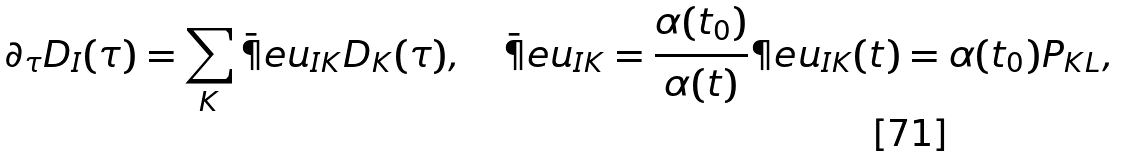Convert formula to latex. <formula><loc_0><loc_0><loc_500><loc_500>\partial _ { \tau } D _ { I } ( \tau ) = \sum _ { K } \bar { \P } e u _ { I K } D _ { K } ( \tau ) , \quad \bar { \P } e u _ { I K } = \frac { \alpha ( t _ { 0 } ) } { \alpha ( t ) } \P e u _ { I K } ( t ) = \alpha ( t _ { 0 } ) P _ { K L } ,</formula> 